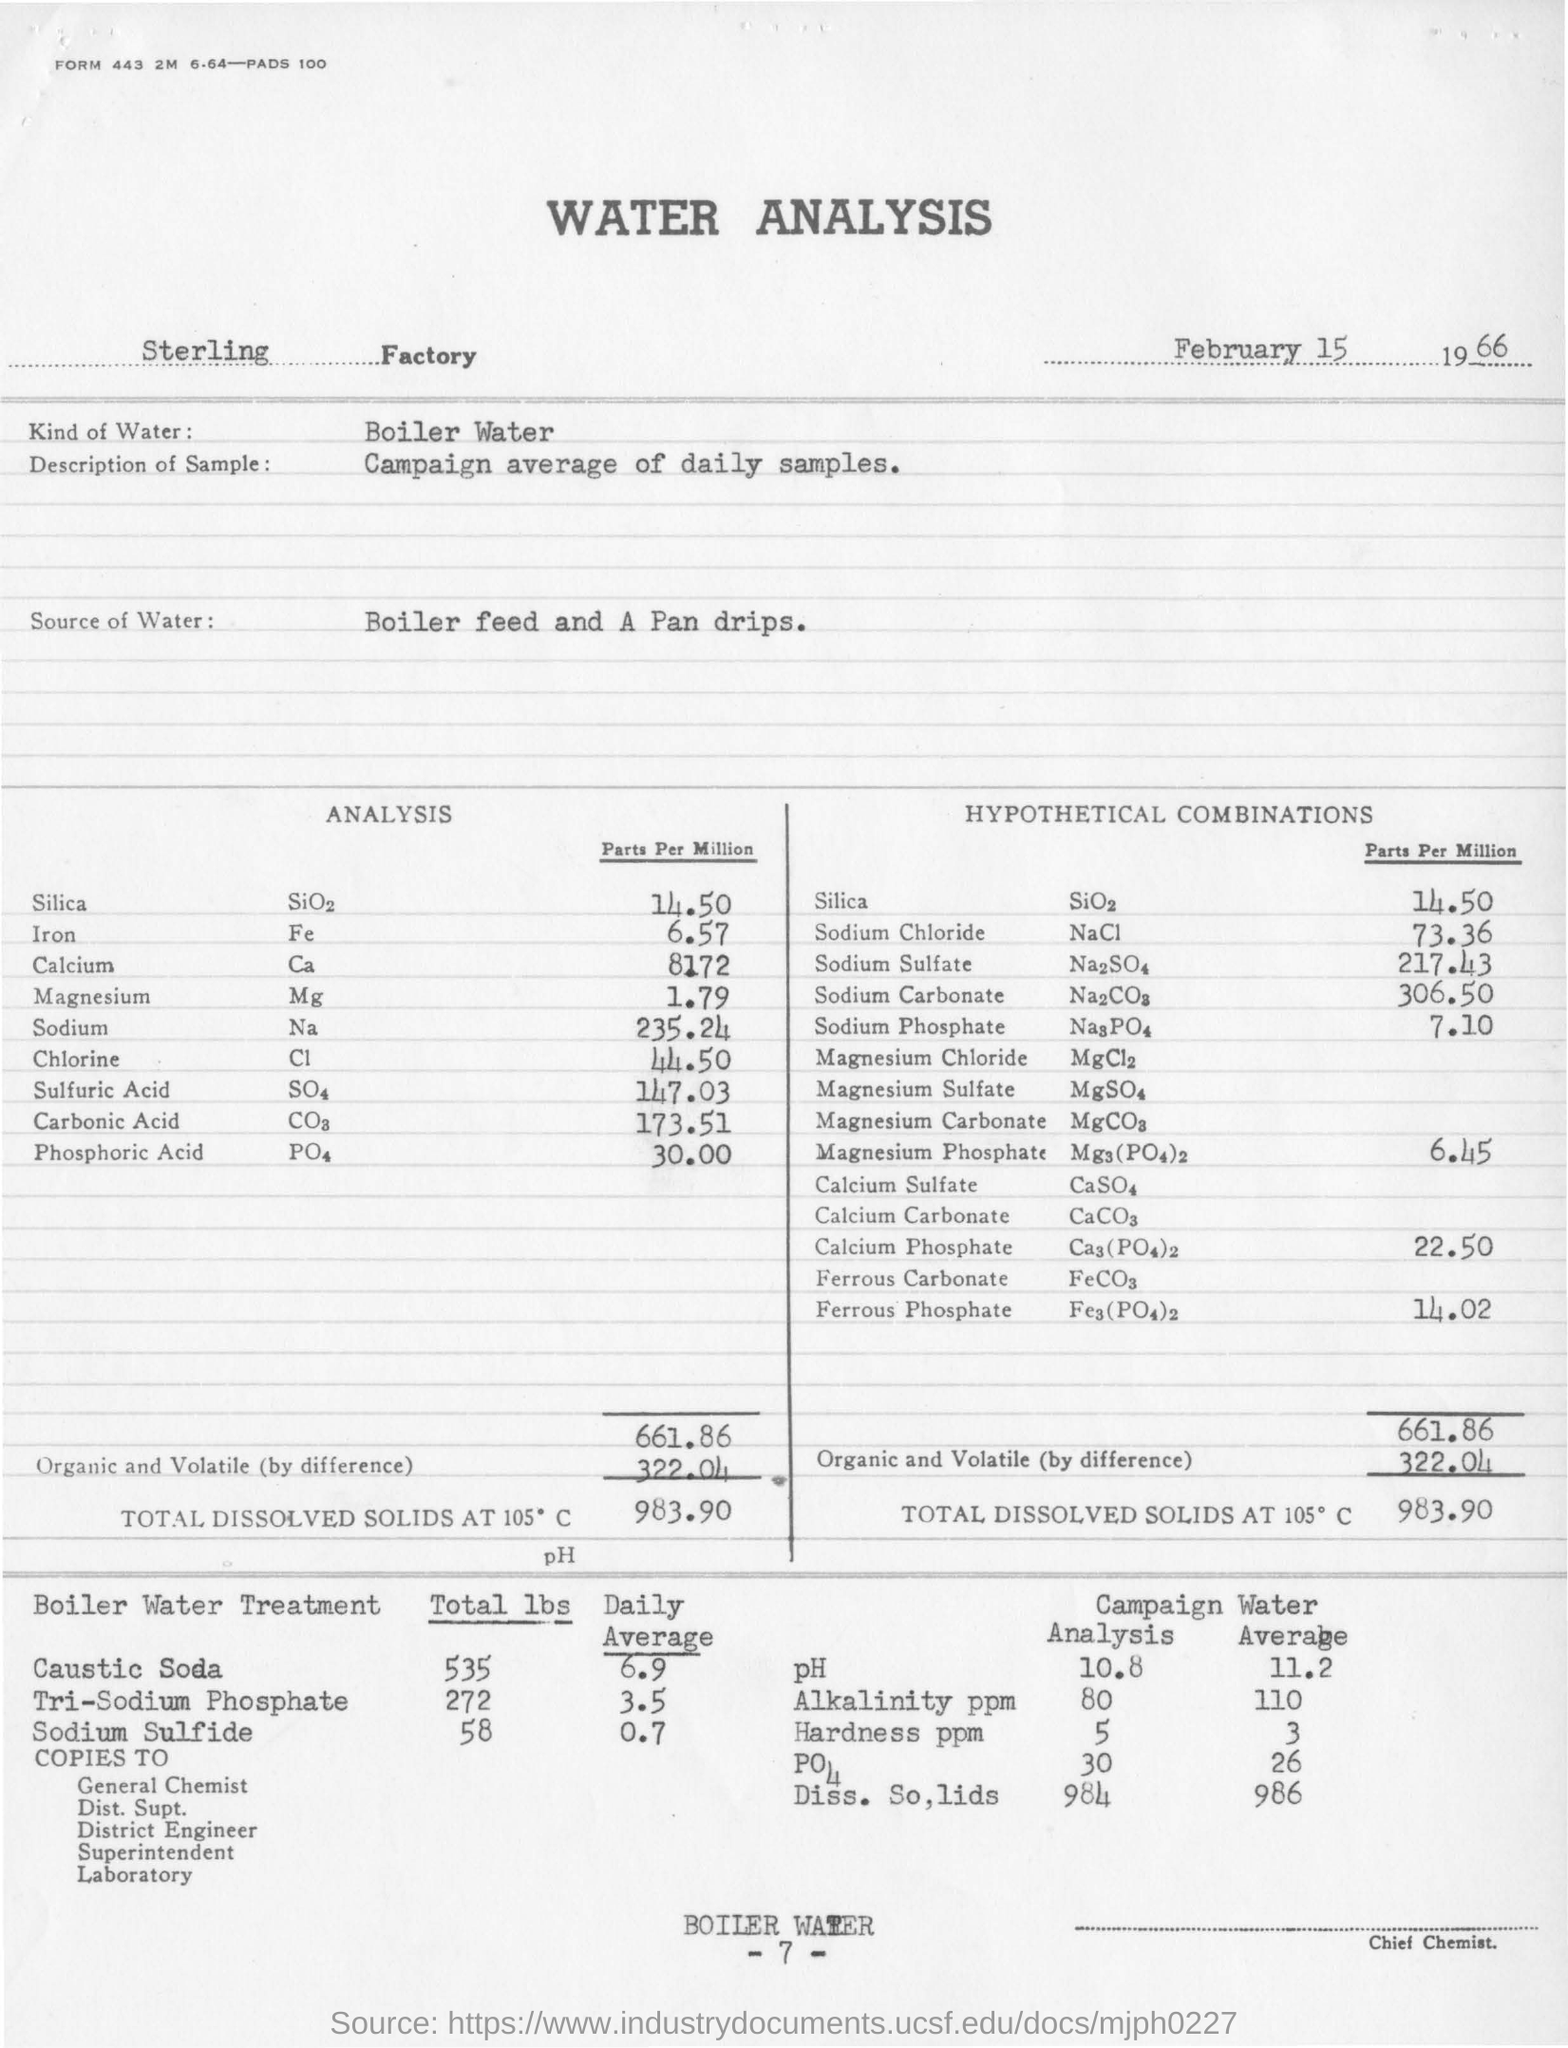What is the name of the factory ?
Keep it short and to the point. Sterling factory. On which date this analysis is done ?
Provide a succinct answer. February 15, 1966. What is the kind of water used in the water analysis ?
Provide a short and direct response. Boiler water. From where the water for analysis is taken ?
Your answer should be very brief. Boiler feed and a pan drips. What is the total lbs of caustic soda used in boiler water treatment ?
Make the answer very short. 535. What is the average value of sodium sulfide used in boiler water treatment ?
Offer a very short reply. 0.7. What is the average value of ph in campaign water ?
Ensure brevity in your answer.  11.2. What is the average value of hardness ppm in campaign water ?
Ensure brevity in your answer.  3. 